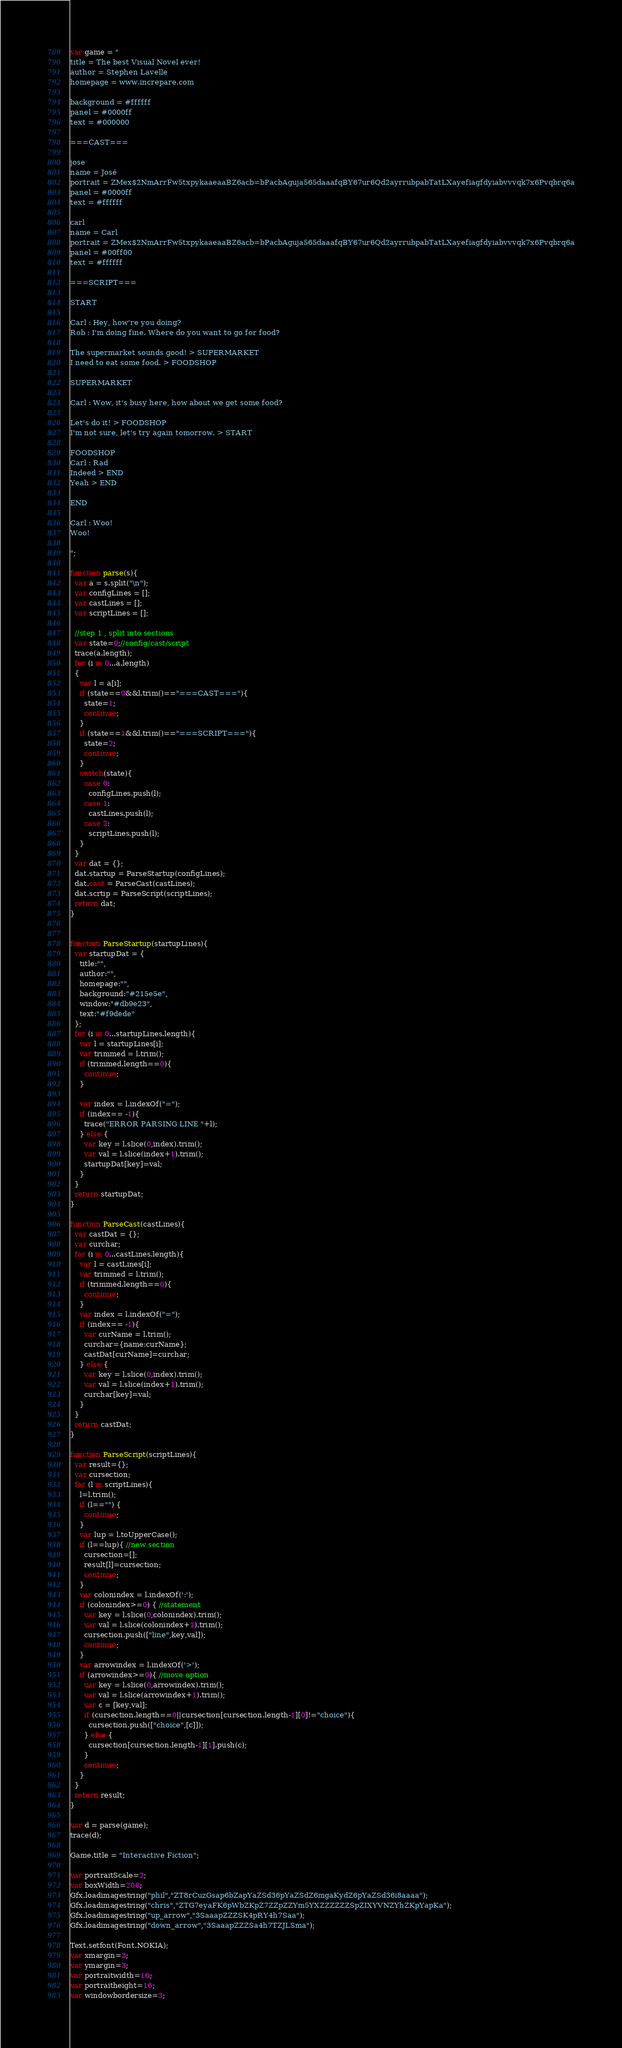Convert code to text. <code><loc_0><loc_0><loc_500><loc_500><_Haxe_>var game = " 
title = The best Visual Novel ever!
author = Stephen Lavelle
homepage = www.increpare.com

background = #ffffff
panel = #0000ff
text = #000000

===CAST===

jose
name = José
portrait = ZMex$2NmArrFw5txpykaaeaaBZ6acb=bPacbAguja565daaafqBY67ur6Qd2ayrrubpabTatLXayefiagfdyiabvvvqk7x6Pvqbrq6a
panel = #0000ff
text = #ffffff

carl
name = Carl
portrait = ZMex$2NmArrFw5txpykaaeaaBZ6acb=bPacbAguja565daaafqBY67ur6Qd2ayrrubpabTatLXayefiagfdyiabvvvqk7x6Pvqbrq6a
panel = #00ff00
text = #ffffff

===SCRIPT===

START

Carl : Hey, how're you doing?
Rob : I'm doing fine. Where do you want to go for food?

The supermarket sounds good! > SUPERMARKET
I need to eat some food. > FOODSHOP

SUPERMARKET

Carl : Wow, it's busy here, how about we get some food?

Let's do it! > FOODSHOP
I'm not sure, let's try again tomorrow. > START

FOODSHOP
Carl : Rad
Indeed > END
Yeah > END

END

Carl : Woo!
Woo!

";

function parse(s){
  var a = s.split("\n");
  var configLines = [];
  var castLines = [];
  var scriptLines = [];
  
  //step 1 , split into sections
  var state=0;//config/cast/script
  trace(a.length);
  for (i in 0...a.length) 
  {    
    var l = a[i];   
    if (state==0&&l.trim()=="===CAST==="){
      state=1;    
      continue;
    }
    if (state==1&&l.trim()=="===SCRIPT==="){
      state=2;       
      continue;
    }
    switch(state){
      case 0:
        configLines.push(l);
      case 1:
        castLines.push(l);
      case 2:
        scriptLines.push(l);
    }
  }
  var dat = {};
  dat.startup = ParseStartup(configLines);
  dat.cast = ParseCast(castLines);
  dat.scrtip = ParseScript(scriptLines);
  return dat;
}


function ParseStartup(startupLines){
  var startupDat = {
    title:"",
    author:"",
    homepage:"",
    background:"#215e5e",
    window:"#db9e23",
    text:"#f9dede"
  };
  for (i in 0...startupLines.length){
    var l = startupLines[i];
    var trimmed = l.trim();
    if (trimmed.length==0){
      continue;
    }
    
    var index = l.indexOf("=");
    if (index== -1){
      trace("ERROR PARSING LINE "+l);
    } else {
      var key = l.slice(0,index).trim();
      var val = l.slice(index+1).trim();
      startupDat[key]=val;
    }
  }
  return startupDat;  
}

function ParseCast(castLines){
  var castDat = {};
  var curchar;
  for (i in 0...castLines.length){
    var l = castLines[i];
    var trimmed = l.trim();
    if (trimmed.length==0){
      continue;
    }
    var index = l.indexOf("=");
    if (index== -1){
      var curName = l.trim();
      curchar={name:curName};
      castDat[curName]=curchar;     
    } else {
      var key = l.slice(0,index).trim();
      var val = l.slice(index+1).trim();
      curchar[key]=val;
    }
  }
  return castDat;  
}

function ParseScript(scriptLines){
  var result={};
  var cursection;
  for (l in scriptLines){
    l=l.trim();
    if (l=="") {
      continue;
    }    
    var lup = l.toUpperCase();   
    if (l==lup){ //new section
      cursection=[];
      result[l]=cursection;    
      continue;      
    }
    var colonindex = l.indexOf(':');
    if (colonindex>=0) { //statement
      var key = l.slice(0,colonindex).trim();
      var val = l.slice(colonindex+1).trim();
      cursection.push(["line",key,val]);
      continue;
    }
    var arrowindex = l.indexOf('>');
    if (arrowindex>=0){ //move option
      var key = l.slice(0,arrowindex).trim();
      var val = l.slice(arrowindex+1).trim();
      var c = [key,val];
      if (cursection.length==0||cursection[cursection.length-1][0]!="choice"){
        cursection.push(["choice",[c]]);
      } else {
        cursection[cursection.length-1][1].push(c);
      }
      continue;
    } 
  }
  return result;
}

var d = parse(game);
trace(d);

Game.title = "Interactive Fiction";

var portraitScale=2;
var boxWidth=200;
Gfx.loadimagestring("phil","ZT8rCuzGsap6bZapYaZSd36pYaZSdZ6mgaKydZ6pYaZSd36i8aaaa");
Gfx.loadimagestring("chris","ZTG7eyaFK6pWbZKpZ7ZZpZZYm5YXZZZZZZSpZIXYVNZYhZKpYapKa");
Gfx.loadimagestring("up_arrow","3SaaapZZZSK4pRY4h7Saa");
Gfx.loadimagestring("down_arrow","3SaaapZZZSa4h7TZJLSma");

Text.setfont(Font.NOKIA);
var xmargin=3;
var ymargin=3;
var portraitwidth=16;
var portraitheight=16;
var windowbordersize=3;</code> 